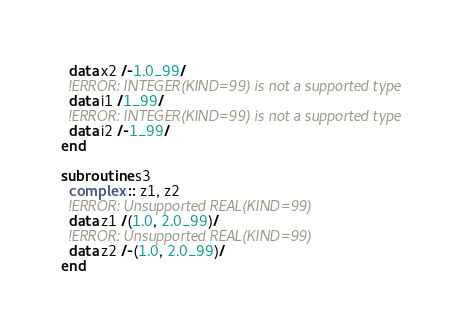Convert code to text. <code><loc_0><loc_0><loc_500><loc_500><_FORTRAN_>  data x2 /-1.0_99/
  !ERROR: INTEGER(KIND=99) is not a supported type
  data i1 /1_99/
  !ERROR: INTEGER(KIND=99) is not a supported type
  data i2 /-1_99/
end

subroutine s3
  complex :: z1, z2
  !ERROR: Unsupported REAL(KIND=99)
  data z1 /(1.0, 2.0_99)/
  !ERROR: Unsupported REAL(KIND=99)
  data z2 /-(1.0, 2.0_99)/
end
</code> 